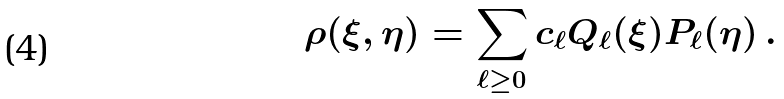<formula> <loc_0><loc_0><loc_500><loc_500>\rho ( \xi , \eta ) = \sum _ { \ell \geq 0 } c _ { \ell } Q _ { \ell } ( \xi ) P _ { \ell } ( \eta ) \, .</formula> 